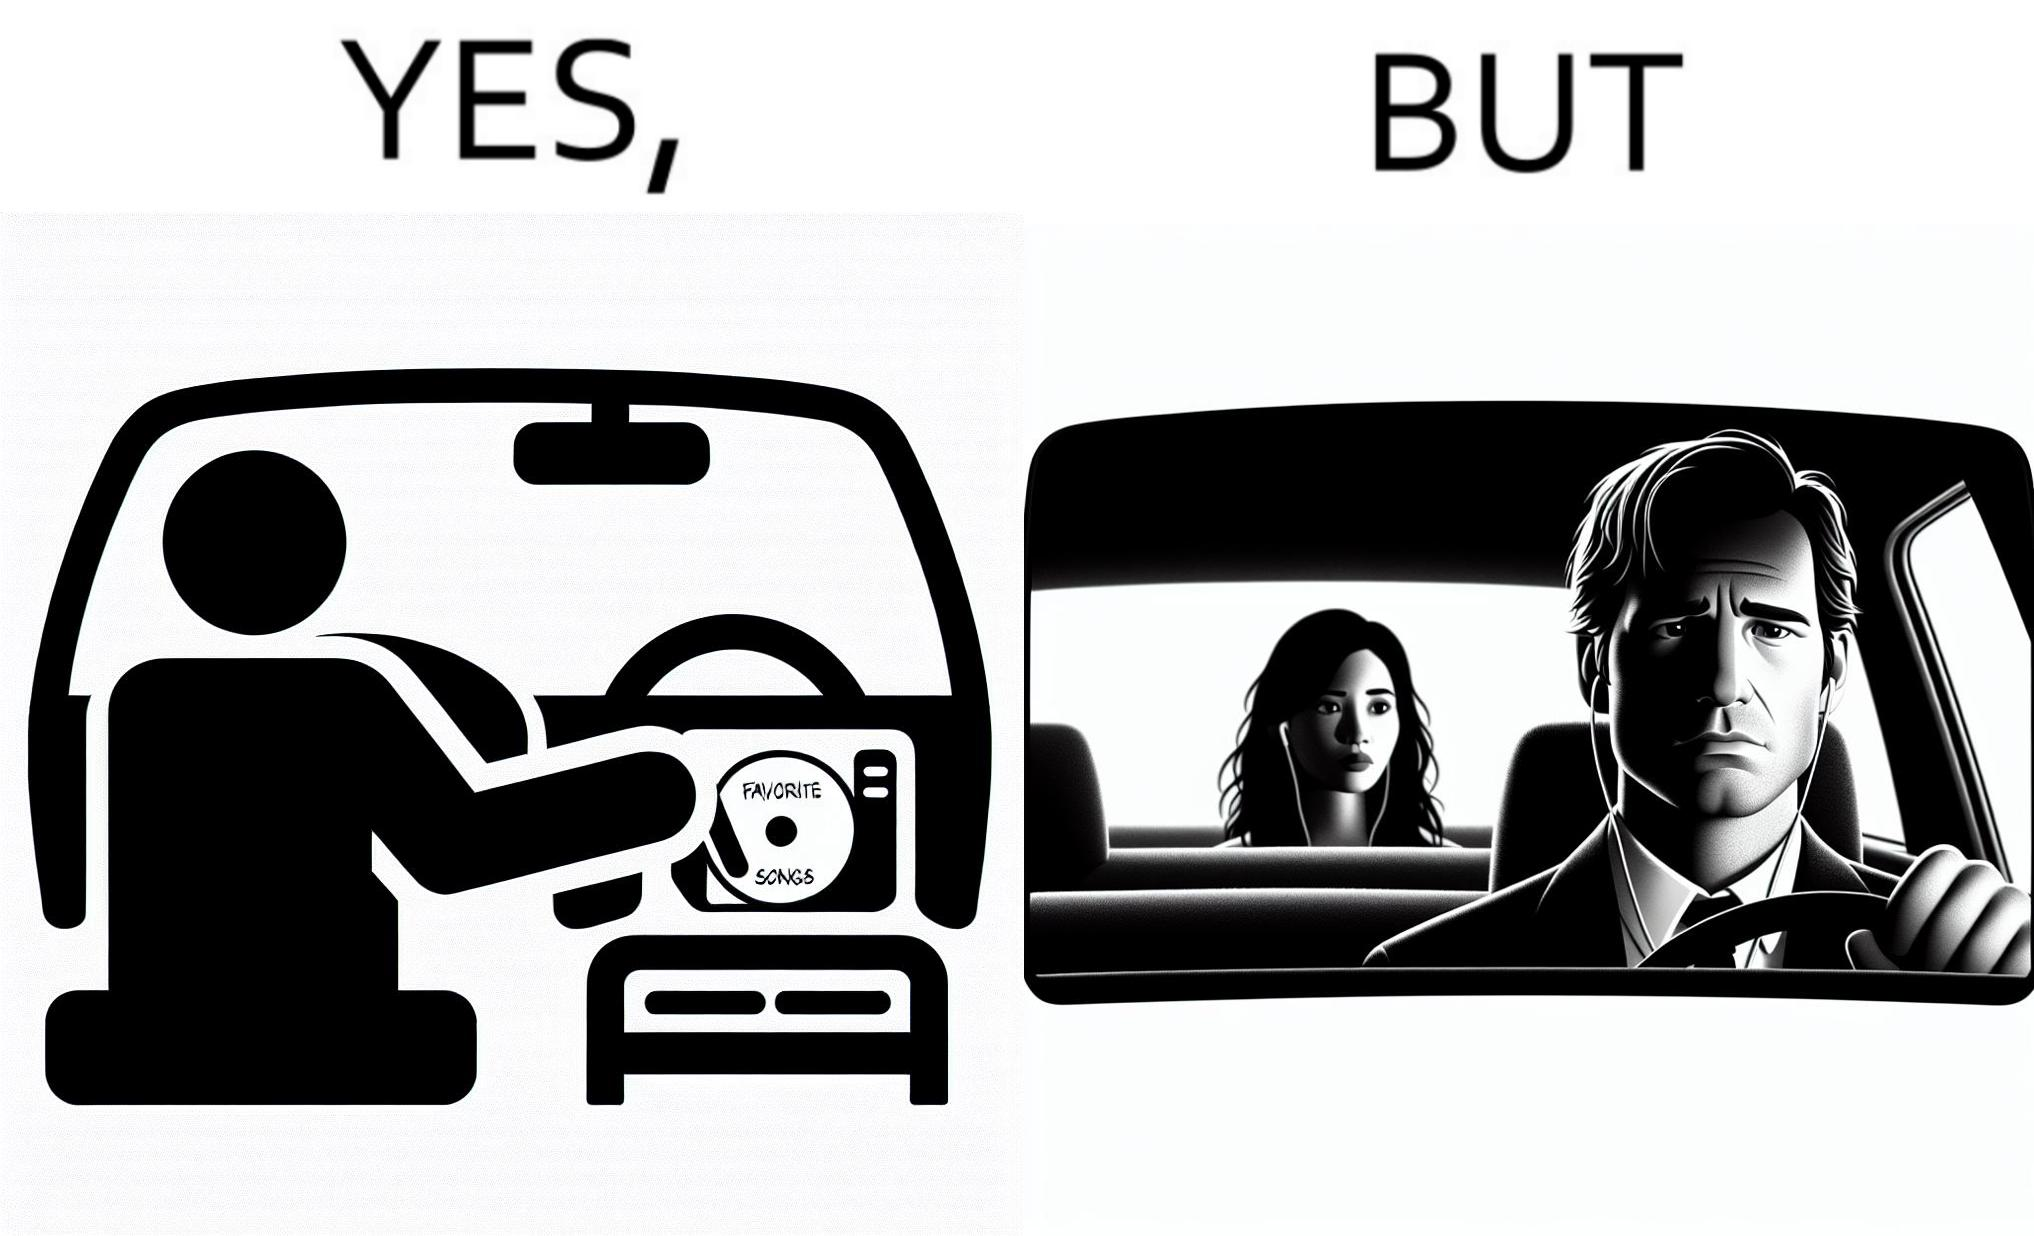Describe what you see in the left and right parts of this image. In the left part of the image: a person in the driving seat is inserting a CD with "Favorite Songs" written on it into the CD player of a car dashboard. In the right part of the image: driver of the car is sad on seeing the person (on the rear view mirror) sitting in the back seat of the car wearing earphones. 